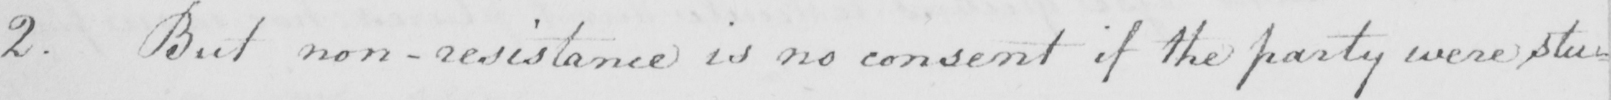What does this handwritten line say? 2 . But non-resistance is no consent if the party were stu- 